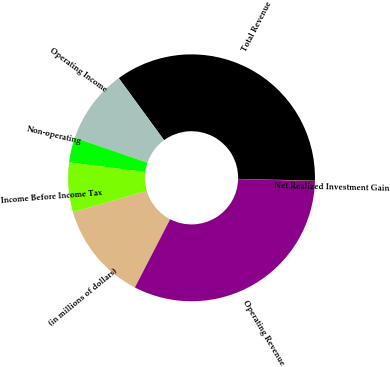<chart> <loc_0><loc_0><loc_500><loc_500><pie_chart><fcel>(in millions of dollars)<fcel>Operating Revenue<fcel>Net Realized Investment Gain<fcel>Total Revenue<fcel>Operating Income<fcel>Non-operating<fcel>Income Before Income Tax<nl><fcel>12.92%<fcel>32.18%<fcel>0.05%<fcel>35.4%<fcel>9.7%<fcel>3.27%<fcel>6.49%<nl></chart> 